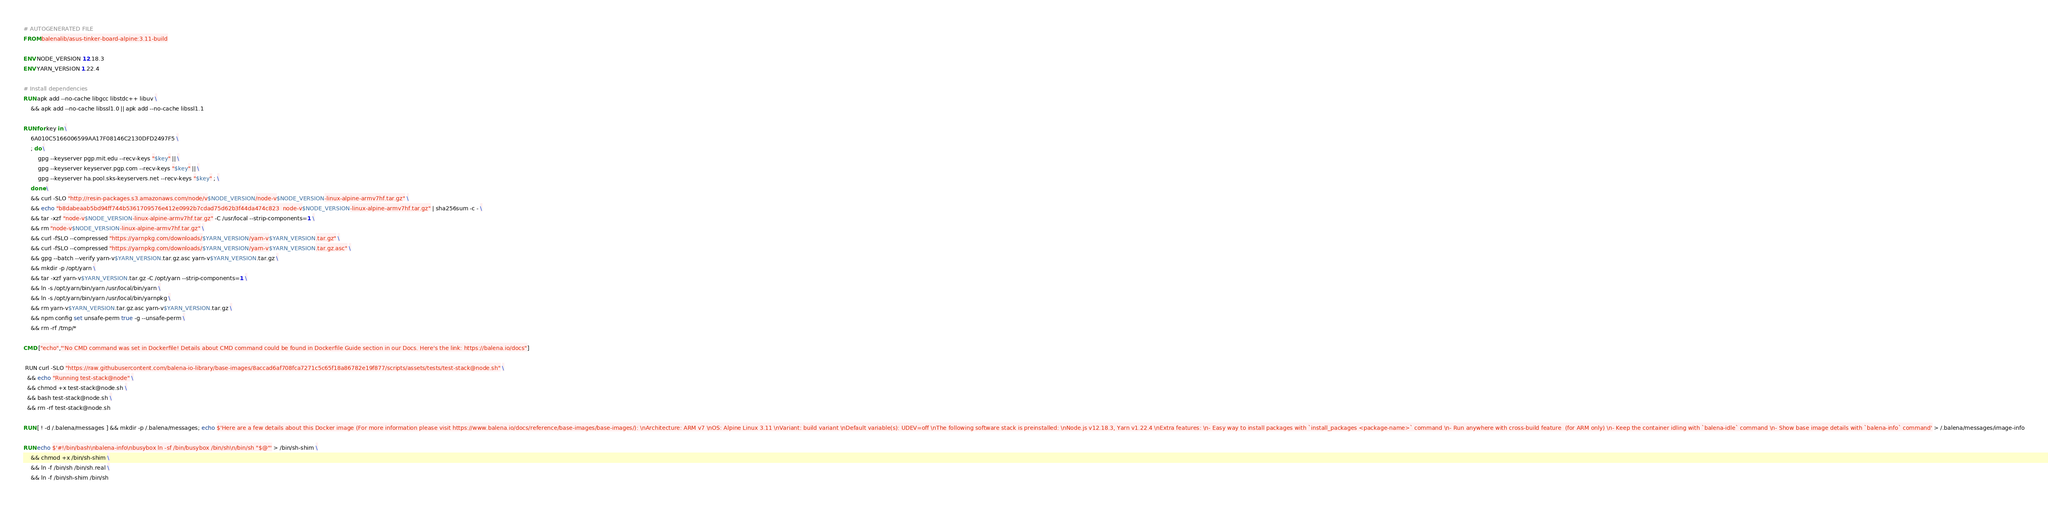Convert code to text. <code><loc_0><loc_0><loc_500><loc_500><_Dockerfile_># AUTOGENERATED FILE
FROM balenalib/asus-tinker-board-alpine:3.11-build

ENV NODE_VERSION 12.18.3
ENV YARN_VERSION 1.22.4

# Install dependencies
RUN apk add --no-cache libgcc libstdc++ libuv \
	&& apk add --no-cache libssl1.0 || apk add --no-cache libssl1.1

RUN for key in \
	6A010C5166006599AA17F08146C2130DFD2497F5 \
	; do \
		gpg --keyserver pgp.mit.edu --recv-keys "$key" || \
		gpg --keyserver keyserver.pgp.com --recv-keys "$key" || \
		gpg --keyserver ha.pool.sks-keyservers.net --recv-keys "$key" ; \
	done \
	&& curl -SLO "http://resin-packages.s3.amazonaws.com/node/v$NODE_VERSION/node-v$NODE_VERSION-linux-alpine-armv7hf.tar.gz" \
	&& echo "b8dabeaab5bd94ff744b5361709576e412e0992b7cdad75d62b3f44da474c823  node-v$NODE_VERSION-linux-alpine-armv7hf.tar.gz" | sha256sum -c - \
	&& tar -xzf "node-v$NODE_VERSION-linux-alpine-armv7hf.tar.gz" -C /usr/local --strip-components=1 \
	&& rm "node-v$NODE_VERSION-linux-alpine-armv7hf.tar.gz" \
	&& curl -fSLO --compressed "https://yarnpkg.com/downloads/$YARN_VERSION/yarn-v$YARN_VERSION.tar.gz" \
	&& curl -fSLO --compressed "https://yarnpkg.com/downloads/$YARN_VERSION/yarn-v$YARN_VERSION.tar.gz.asc" \
	&& gpg --batch --verify yarn-v$YARN_VERSION.tar.gz.asc yarn-v$YARN_VERSION.tar.gz \
	&& mkdir -p /opt/yarn \
	&& tar -xzf yarn-v$YARN_VERSION.tar.gz -C /opt/yarn --strip-components=1 \
	&& ln -s /opt/yarn/bin/yarn /usr/local/bin/yarn \
	&& ln -s /opt/yarn/bin/yarn /usr/local/bin/yarnpkg \
	&& rm yarn-v$YARN_VERSION.tar.gz.asc yarn-v$YARN_VERSION.tar.gz \
	&& npm config set unsafe-perm true -g --unsafe-perm \
	&& rm -rf /tmp/*

CMD ["echo","'No CMD command was set in Dockerfile! Details about CMD command could be found in Dockerfile Guide section in our Docs. Here's the link: https://balena.io/docs"]

 RUN curl -SLO "https://raw.githubusercontent.com/balena-io-library/base-images/8accad6af708fca7271c5c65f18a86782e19f877/scripts/assets/tests/test-stack@node.sh" \
  && echo "Running test-stack@node" \
  && chmod +x test-stack@node.sh \
  && bash test-stack@node.sh \
  && rm -rf test-stack@node.sh 

RUN [ ! -d /.balena/messages ] && mkdir -p /.balena/messages; echo $'Here are a few details about this Docker image (For more information please visit https://www.balena.io/docs/reference/base-images/base-images/): \nArchitecture: ARM v7 \nOS: Alpine Linux 3.11 \nVariant: build variant \nDefault variable(s): UDEV=off \nThe following software stack is preinstalled: \nNode.js v12.18.3, Yarn v1.22.4 \nExtra features: \n- Easy way to install packages with `install_packages <package-name>` command \n- Run anywhere with cross-build feature  (for ARM only) \n- Keep the container idling with `balena-idle` command \n- Show base image details with `balena-info` command' > /.balena/messages/image-info

RUN echo $'#!/bin/bash\nbalena-info\nbusybox ln -sf /bin/busybox /bin/sh\n/bin/sh "$@"' > /bin/sh-shim \
	&& chmod +x /bin/sh-shim \
	&& ln -f /bin/sh /bin/sh.real \
	&& ln -f /bin/sh-shim /bin/sh</code> 